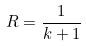Convert formula to latex. <formula><loc_0><loc_0><loc_500><loc_500>R = \frac { 1 } { k + 1 }</formula> 